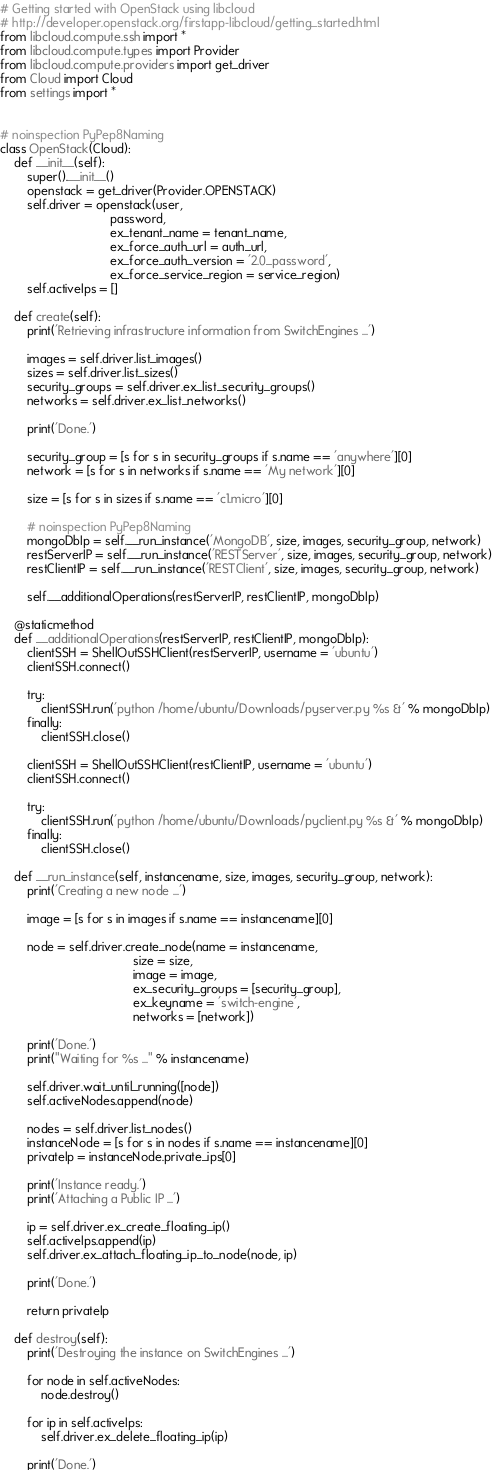Convert code to text. <code><loc_0><loc_0><loc_500><loc_500><_Python_># Getting started with OpenStack using libcloud
# http://developer.openstack.org/firstapp-libcloud/getting_started.html
from libcloud.compute.ssh import *
from libcloud.compute.types import Provider
from libcloud.compute.providers import get_driver
from Cloud import Cloud
from settings import *


# noinspection PyPep8Naming
class OpenStack(Cloud):
    def __init__(self):
        super().__init__()
        openstack = get_driver(Provider.OPENSTACK)
        self.driver = openstack(user,
                                password,
                                ex_tenant_name = tenant_name,
                                ex_force_auth_url = auth_url,
                                ex_force_auth_version = '2.0_password',
                                ex_force_service_region = service_region)
        self.activeIps = []

    def create(self):
        print('Retrieving infrastructure information from SwitchEngines ...')

        images = self.driver.list_images()
        sizes = self.driver.list_sizes()
        security_groups = self.driver.ex_list_security_groups()
        networks = self.driver.ex_list_networks()

        print('Done.')

        security_group = [s for s in security_groups if s.name == 'anywhere'][0]
        network = [s for s in networks if s.name == 'My network'][0]

        size = [s for s in sizes if s.name == 'c1.micro'][0]

        # noinspection PyPep8Naming
        mongoDbIp = self.__run_instance('MongoDB', size, images, security_group, network)
        restServerIP = self.__run_instance('RESTServer', size, images, security_group, network)
        restClientIP = self.__run_instance('RESTClient', size, images, security_group, network)

        self.__additionalOperations(restServerIP, restClientIP, mongoDbIp)

    @staticmethod
    def __additionalOperations(restServerIP, restClientIP, mongoDbIp):
        clientSSH = ShellOutSSHClient(restServerIP, username = 'ubuntu')
        clientSSH.connect()

        try:
            clientSSH.run('python /home/ubuntu/Downloads/pyserver.py %s &' % mongoDbIp)
        finally:
            clientSSH.close()

        clientSSH = ShellOutSSHClient(restClientIP, username = 'ubuntu')
        clientSSH.connect()

        try:
            clientSSH.run('python /home/ubuntu/Downloads/pyclient.py %s &' % mongoDbIp)
        finally:
            clientSSH.close()

    def __run_instance(self, instancename, size, images, security_group, network):
        print('Creating a new node ...')

        image = [s for s in images if s.name == instancename][0]

        node = self.driver.create_node(name = instancename,
                                       size = size,
                                       image = image,
                                       ex_security_groups = [security_group],
                                       ex_keyname = 'switch-engine',
                                       networks = [network])

        print('Done.')
        print("Waiting for %s ..." % instancename)

        self.driver.wait_until_running([node])
        self.activeNodes.append(node)

        nodes = self.driver.list_nodes()
        instanceNode = [s for s in nodes if s.name == instancename][0]
        privateIp = instanceNode.private_ips[0]

        print('Instance ready.')
        print('Attaching a Public IP ...')

        ip = self.driver.ex_create_floating_ip()
        self.activeIps.append(ip)
        self.driver.ex_attach_floating_ip_to_node(node, ip)

        print('Done.')

        return privateIp

    def destroy(self):
        print('Destroying the instance on SwitchEngines ...')

        for node in self.activeNodes:
            node.destroy()

        for ip in self.activeIps:
            self.driver.ex_delete_floating_ip(ip)

        print('Done.')
</code> 